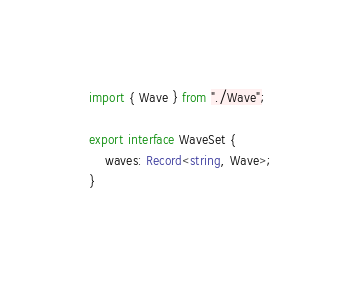Convert code to text. <code><loc_0><loc_0><loc_500><loc_500><_TypeScript_>import { Wave } from "./Wave";

export interface WaveSet {
	waves: Record<string, Wave>;
}
</code> 